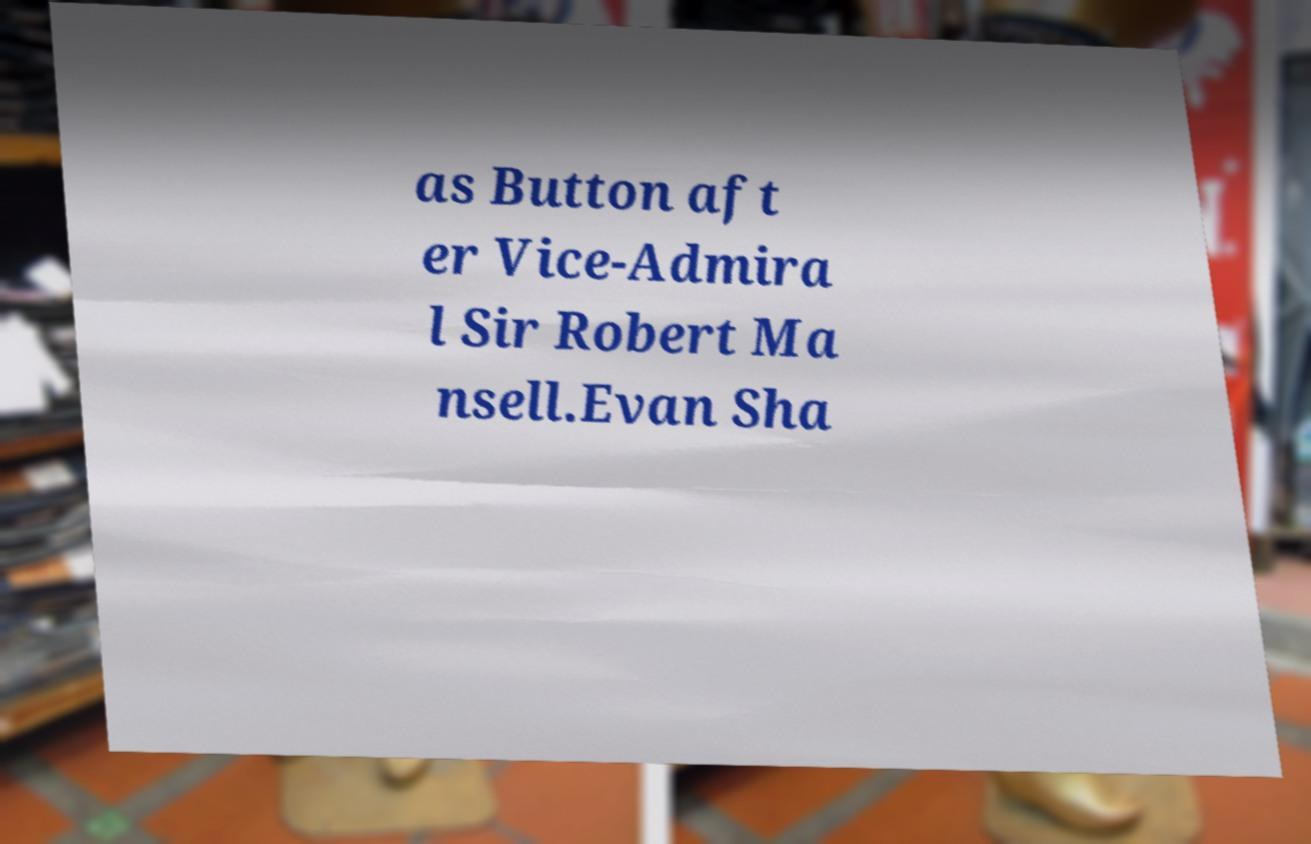Could you extract and type out the text from this image? as Button aft er Vice-Admira l Sir Robert Ma nsell.Evan Sha 